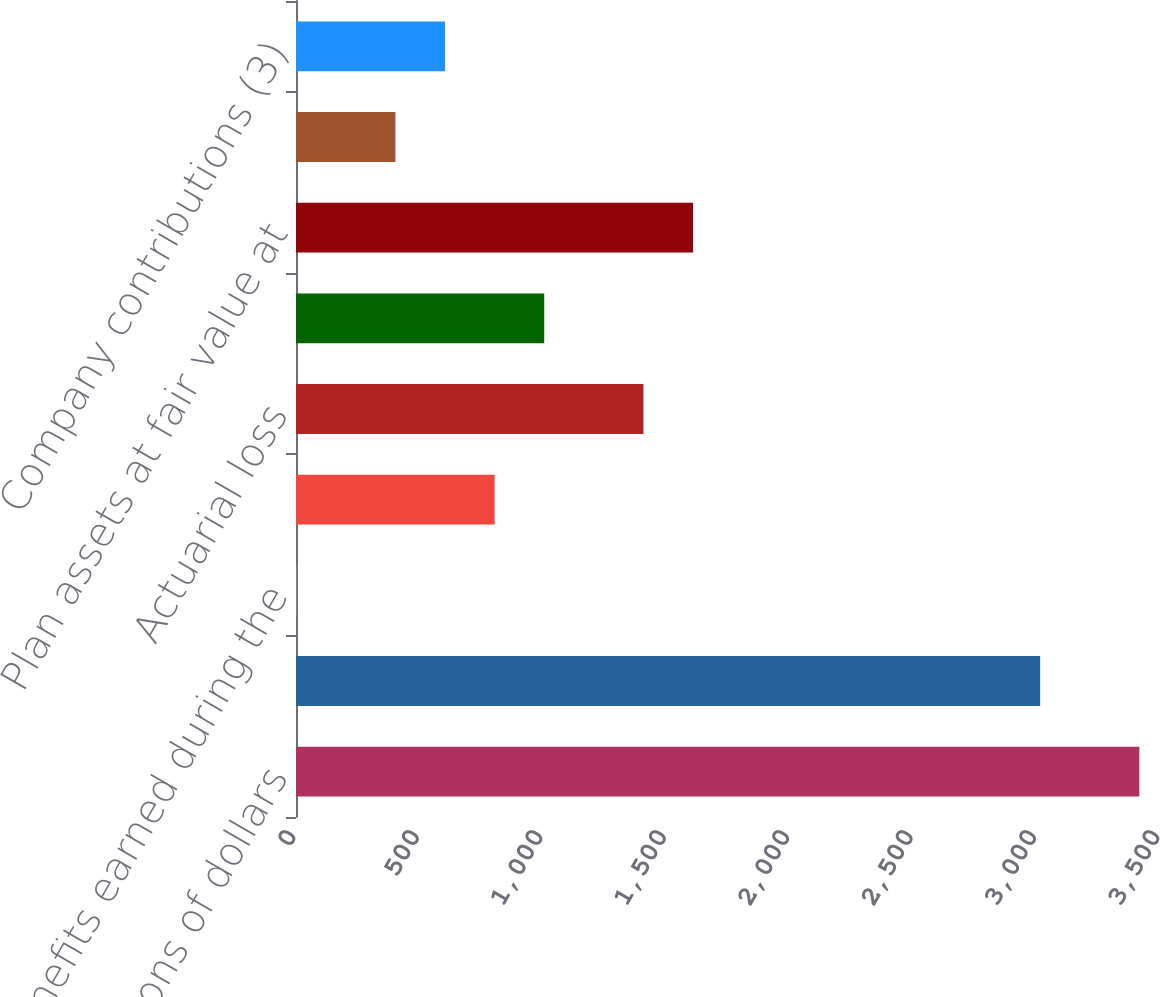<chart> <loc_0><loc_0><loc_500><loc_500><bar_chart><fcel>In millions of dollars<fcel>Projected benefit obligation<fcel>Benefits earned during the<fcel>Interest cost on benefit<fcel>Actuarial loss<fcel>Benefits paid<fcel>Plan assets at fair value at<fcel>Actual return on plan assets<fcel>Company contributions (3)<nl><fcel>3416.3<fcel>3014.5<fcel>1<fcel>804.6<fcel>1407.3<fcel>1005.5<fcel>1608.2<fcel>402.8<fcel>603.7<nl></chart> 